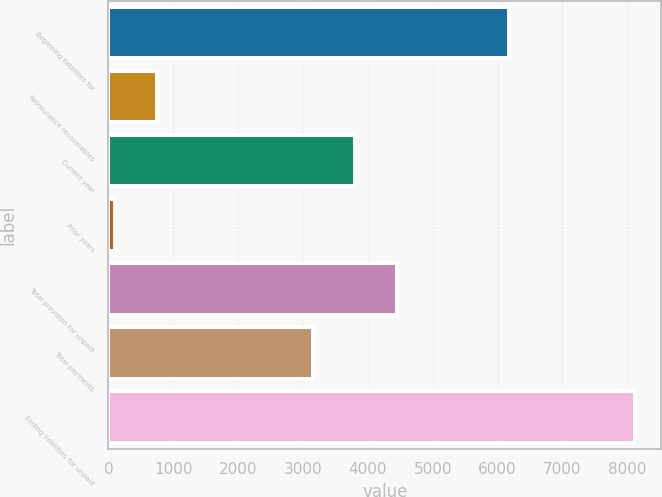Convert chart to OTSL. <chart><loc_0><loc_0><loc_500><loc_500><bar_chart><fcel>Beginning liabilities for<fcel>Reinsurance recoverables<fcel>Current year<fcel>Prior years<fcel>Total provision for unpaid<fcel>Total payments<fcel>Ending liabilities for unpaid<nl><fcel>6179<fcel>742.9<fcel>3803.9<fcel>98<fcel>4448.8<fcel>3159<fcel>8113.7<nl></chart> 